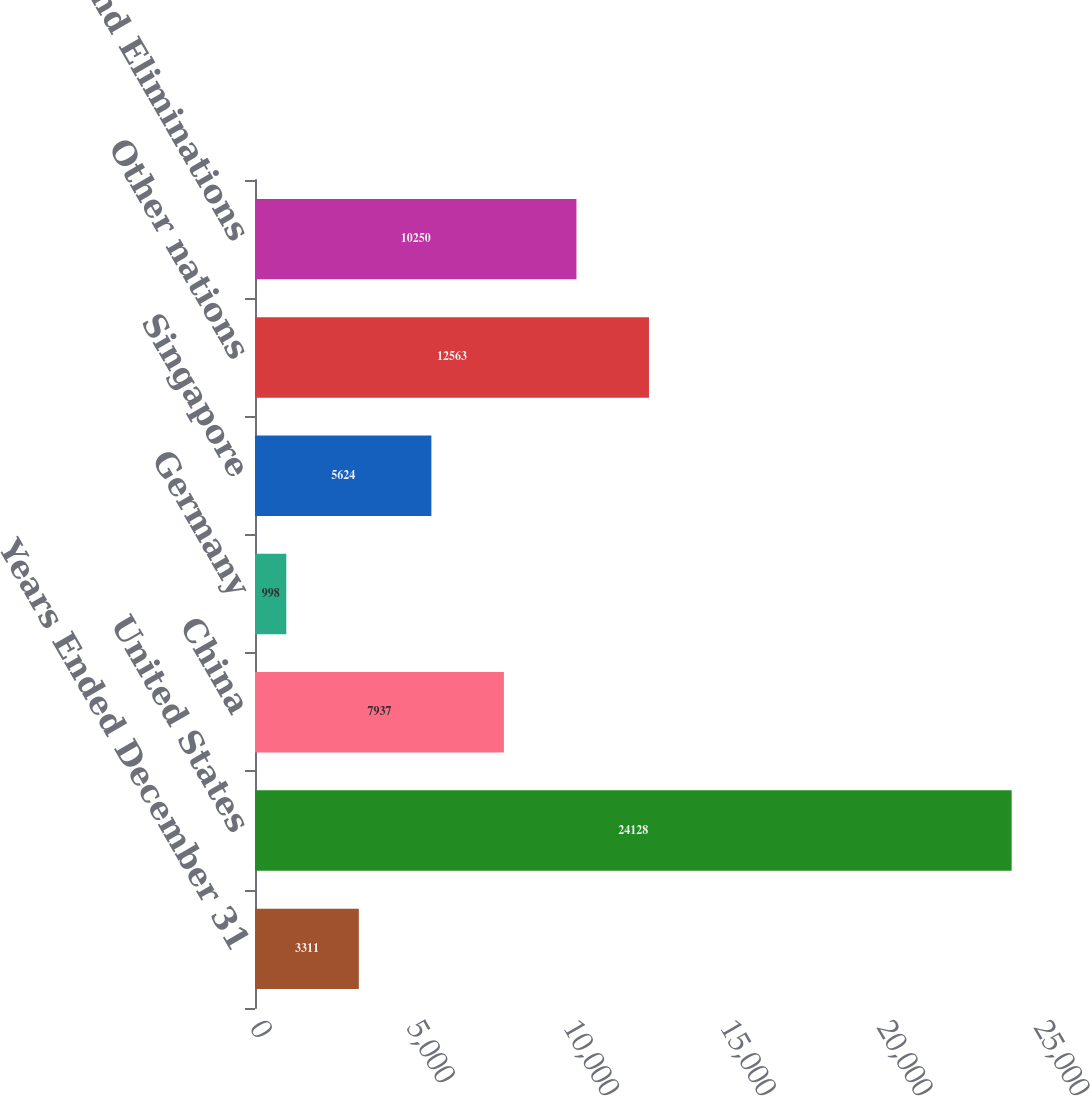Convert chart. <chart><loc_0><loc_0><loc_500><loc_500><bar_chart><fcel>Years Ended December 31<fcel>United States<fcel>China<fcel>Germany<fcel>Singapore<fcel>Other nations<fcel>Adjustments and Eliminations<nl><fcel>3311<fcel>24128<fcel>7937<fcel>998<fcel>5624<fcel>12563<fcel>10250<nl></chart> 